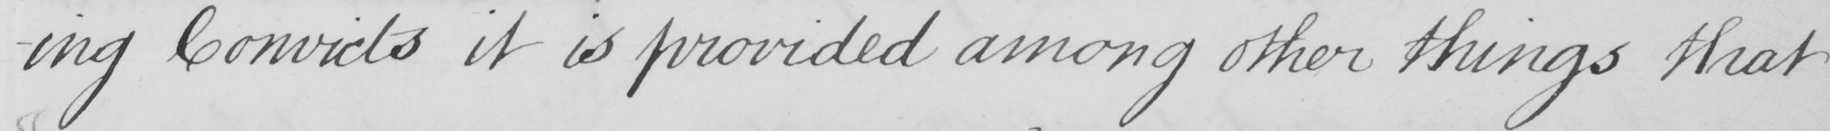What text is written in this handwritten line? -ing Convicts it is provided among other things that 